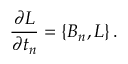<formula> <loc_0><loc_0><loc_500><loc_500>{ \frac { \partial L } { \partial t _ { n } } } = \{ B _ { n } , L \} \, .</formula> 